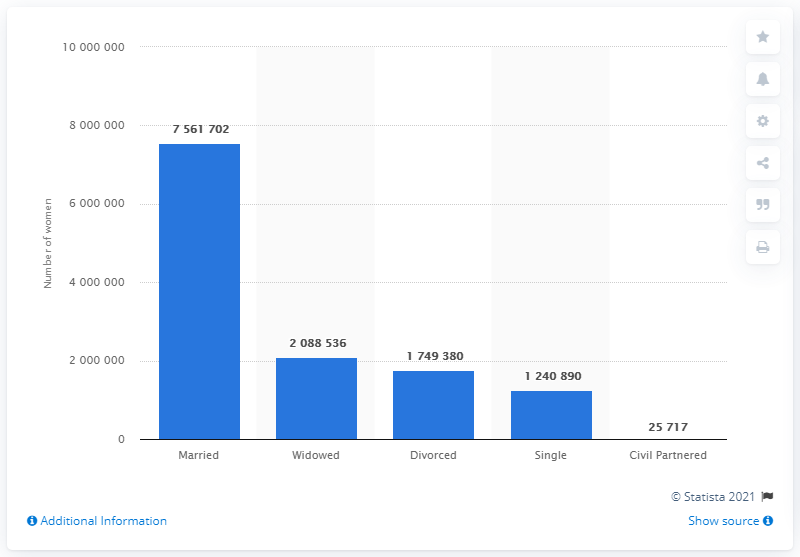Give some essential details in this illustration. As of 2017, there were 1240890 women in England who were aged over 45 and single. 